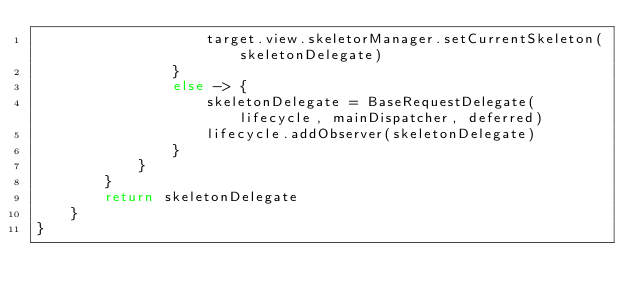<code> <loc_0><loc_0><loc_500><loc_500><_Kotlin_>                    target.view.skeletorManager.setCurrentSkeleton(skeletonDelegate)
                }
                else -> {
                    skeletonDelegate = BaseRequestDelegate(lifecycle, mainDispatcher, deferred)
                    lifecycle.addObserver(skeletonDelegate)
                }
            }
        }
        return skeletonDelegate
    }
}
</code> 